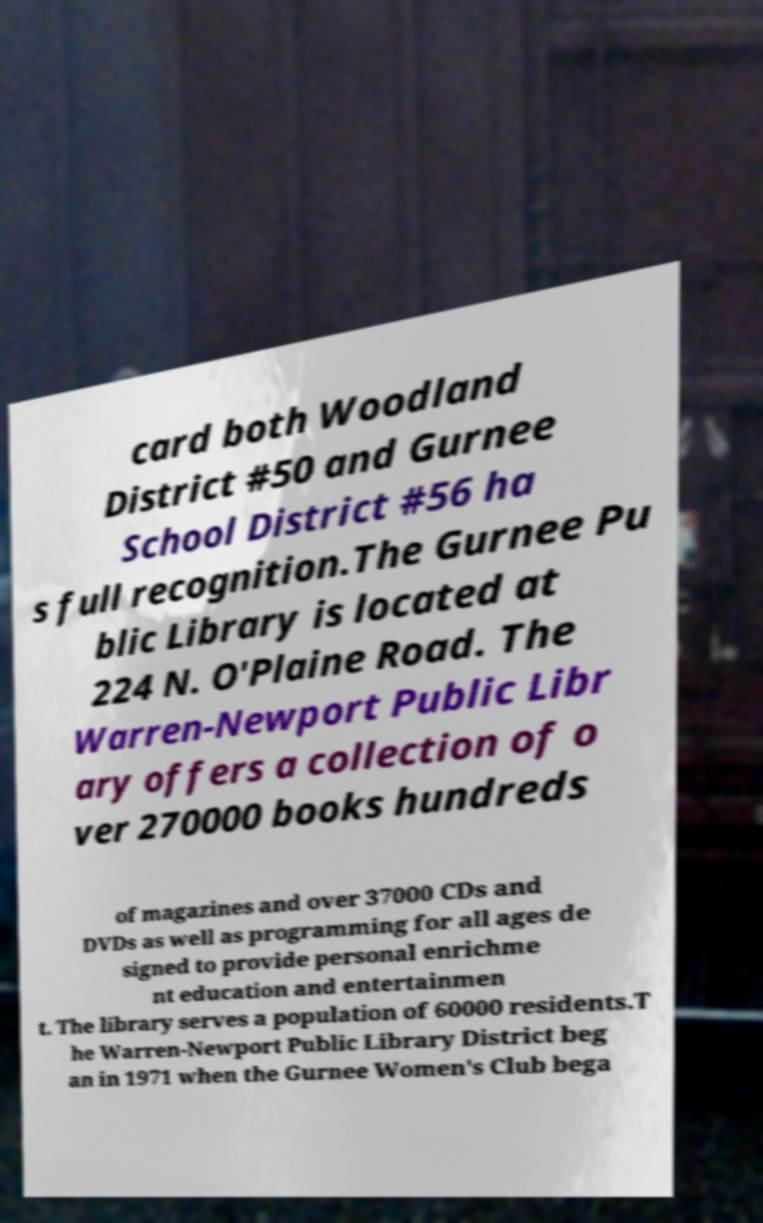I need the written content from this picture converted into text. Can you do that? card both Woodland District #50 and Gurnee School District #56 ha s full recognition.The Gurnee Pu blic Library is located at 224 N. O'Plaine Road. The Warren-Newport Public Libr ary offers a collection of o ver 270000 books hundreds of magazines and over 37000 CDs and DVDs as well as programming for all ages de signed to provide personal enrichme nt education and entertainmen t. The library serves a population of 60000 residents.T he Warren-Newport Public Library District beg an in 1971 when the Gurnee Women's Club bega 